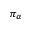Convert formula to latex. <formula><loc_0><loc_0><loc_500><loc_500>\pi _ { \alpha }</formula> 